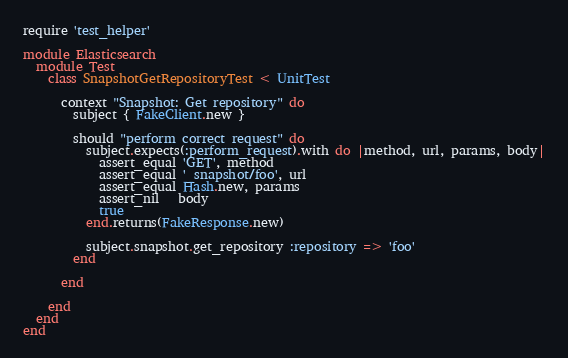<code> <loc_0><loc_0><loc_500><loc_500><_Ruby_>require 'test_helper'

module Elasticsearch
  module Test
    class SnapshotGetRepositoryTest < UnitTest

      context "Snapshot: Get repository" do
        subject { FakeClient.new }

        should "perform correct request" do
          subject.expects(:perform_request).with do |method, url, params, body|
            assert_equal 'GET', method
            assert_equal '_snapshot/foo', url
            assert_equal Hash.new, params
            assert_nil   body
            true
          end.returns(FakeResponse.new)

          subject.snapshot.get_repository :repository => 'foo'
        end

      end

    end
  end
end
</code> 